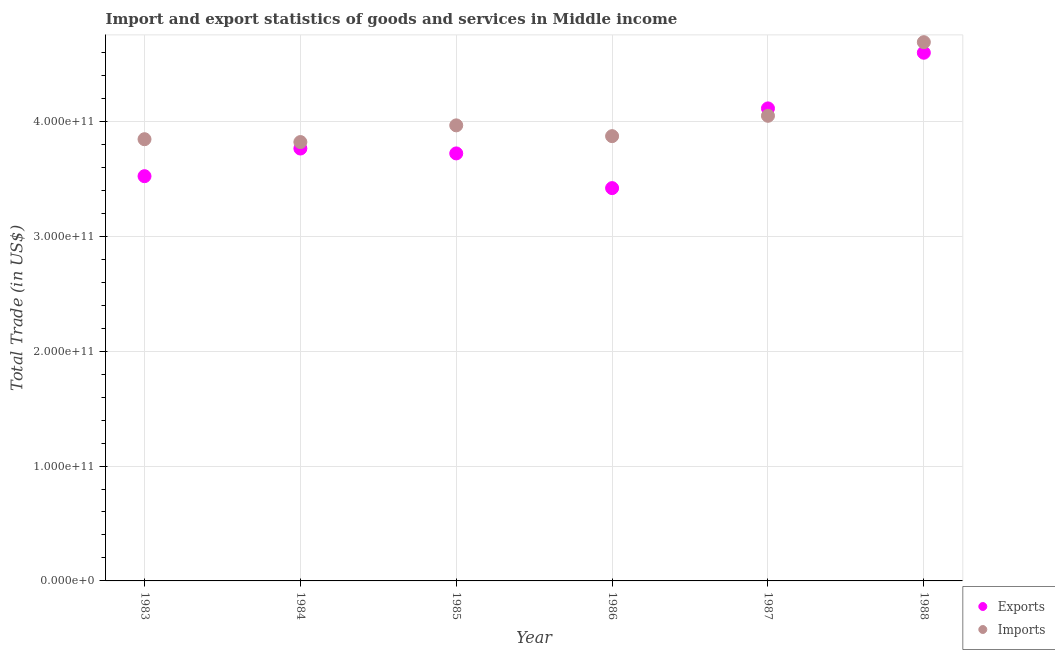How many different coloured dotlines are there?
Make the answer very short. 2. What is the export of goods and services in 1987?
Your response must be concise. 4.11e+11. Across all years, what is the maximum imports of goods and services?
Your answer should be compact. 4.69e+11. Across all years, what is the minimum export of goods and services?
Ensure brevity in your answer.  3.42e+11. What is the total imports of goods and services in the graph?
Keep it short and to the point. 2.42e+12. What is the difference between the export of goods and services in 1984 and that in 1986?
Your answer should be very brief. 3.45e+1. What is the difference between the export of goods and services in 1988 and the imports of goods and services in 1984?
Your answer should be compact. 7.77e+1. What is the average export of goods and services per year?
Offer a terse response. 3.86e+11. In the year 1986, what is the difference between the export of goods and services and imports of goods and services?
Offer a very short reply. -4.52e+1. In how many years, is the imports of goods and services greater than 20000000000 US$?
Offer a very short reply. 6. What is the ratio of the export of goods and services in 1984 to that in 1987?
Your answer should be very brief. 0.92. What is the difference between the highest and the second highest imports of goods and services?
Provide a short and direct response. 6.41e+1. What is the difference between the highest and the lowest imports of goods and services?
Offer a very short reply. 8.69e+1. Is the sum of the export of goods and services in 1986 and 1988 greater than the maximum imports of goods and services across all years?
Keep it short and to the point. Yes. Is the export of goods and services strictly less than the imports of goods and services over the years?
Ensure brevity in your answer.  No. How many dotlines are there?
Your answer should be compact. 2. How many years are there in the graph?
Provide a short and direct response. 6. What is the difference between two consecutive major ticks on the Y-axis?
Offer a very short reply. 1.00e+11. Where does the legend appear in the graph?
Your answer should be very brief. Bottom right. How are the legend labels stacked?
Your answer should be very brief. Vertical. What is the title of the graph?
Your answer should be very brief. Import and export statistics of goods and services in Middle income. What is the label or title of the X-axis?
Offer a very short reply. Year. What is the label or title of the Y-axis?
Offer a very short reply. Total Trade (in US$). What is the Total Trade (in US$) of Exports in 1983?
Your response must be concise. 3.52e+11. What is the Total Trade (in US$) in Imports in 1983?
Your response must be concise. 3.84e+11. What is the Total Trade (in US$) in Exports in 1984?
Keep it short and to the point. 3.76e+11. What is the Total Trade (in US$) of Imports in 1984?
Offer a terse response. 3.82e+11. What is the Total Trade (in US$) of Exports in 1985?
Make the answer very short. 3.72e+11. What is the Total Trade (in US$) of Imports in 1985?
Your answer should be very brief. 3.96e+11. What is the Total Trade (in US$) of Exports in 1986?
Ensure brevity in your answer.  3.42e+11. What is the Total Trade (in US$) in Imports in 1986?
Keep it short and to the point. 3.87e+11. What is the Total Trade (in US$) in Exports in 1987?
Offer a terse response. 4.11e+11. What is the Total Trade (in US$) of Imports in 1987?
Your answer should be compact. 4.05e+11. What is the Total Trade (in US$) of Exports in 1988?
Provide a short and direct response. 4.60e+11. What is the Total Trade (in US$) of Imports in 1988?
Ensure brevity in your answer.  4.69e+11. Across all years, what is the maximum Total Trade (in US$) in Exports?
Offer a terse response. 4.60e+11. Across all years, what is the maximum Total Trade (in US$) of Imports?
Give a very brief answer. 4.69e+11. Across all years, what is the minimum Total Trade (in US$) in Exports?
Offer a very short reply. 3.42e+11. Across all years, what is the minimum Total Trade (in US$) in Imports?
Your answer should be compact. 3.82e+11. What is the total Total Trade (in US$) of Exports in the graph?
Provide a short and direct response. 2.31e+12. What is the total Total Trade (in US$) in Imports in the graph?
Your answer should be very brief. 2.42e+12. What is the difference between the Total Trade (in US$) of Exports in 1983 and that in 1984?
Offer a terse response. -2.41e+1. What is the difference between the Total Trade (in US$) of Imports in 1983 and that in 1984?
Offer a very short reply. 2.48e+09. What is the difference between the Total Trade (in US$) of Exports in 1983 and that in 1985?
Your answer should be compact. -1.98e+1. What is the difference between the Total Trade (in US$) of Imports in 1983 and that in 1985?
Provide a short and direct response. -1.20e+1. What is the difference between the Total Trade (in US$) of Exports in 1983 and that in 1986?
Your answer should be compact. 1.04e+1. What is the difference between the Total Trade (in US$) of Imports in 1983 and that in 1986?
Offer a terse response. -2.66e+09. What is the difference between the Total Trade (in US$) in Exports in 1983 and that in 1987?
Give a very brief answer. -5.90e+1. What is the difference between the Total Trade (in US$) of Imports in 1983 and that in 1987?
Your answer should be compact. -2.04e+1. What is the difference between the Total Trade (in US$) of Exports in 1983 and that in 1988?
Provide a succinct answer. -1.07e+11. What is the difference between the Total Trade (in US$) in Imports in 1983 and that in 1988?
Your answer should be very brief. -8.45e+1. What is the difference between the Total Trade (in US$) of Exports in 1984 and that in 1985?
Your answer should be very brief. 4.25e+09. What is the difference between the Total Trade (in US$) in Imports in 1984 and that in 1985?
Make the answer very short. -1.45e+1. What is the difference between the Total Trade (in US$) in Exports in 1984 and that in 1986?
Offer a very short reply. 3.45e+1. What is the difference between the Total Trade (in US$) of Imports in 1984 and that in 1986?
Offer a terse response. -5.14e+09. What is the difference between the Total Trade (in US$) in Exports in 1984 and that in 1987?
Keep it short and to the point. -3.49e+1. What is the difference between the Total Trade (in US$) in Imports in 1984 and that in 1987?
Provide a short and direct response. -2.29e+1. What is the difference between the Total Trade (in US$) in Exports in 1984 and that in 1988?
Ensure brevity in your answer.  -8.34e+1. What is the difference between the Total Trade (in US$) of Imports in 1984 and that in 1988?
Keep it short and to the point. -8.69e+1. What is the difference between the Total Trade (in US$) in Exports in 1985 and that in 1986?
Provide a succinct answer. 3.02e+1. What is the difference between the Total Trade (in US$) of Imports in 1985 and that in 1986?
Your response must be concise. 9.39e+09. What is the difference between the Total Trade (in US$) of Exports in 1985 and that in 1987?
Provide a succinct answer. -3.92e+1. What is the difference between the Total Trade (in US$) of Imports in 1985 and that in 1987?
Offer a very short reply. -8.33e+09. What is the difference between the Total Trade (in US$) of Exports in 1985 and that in 1988?
Offer a very short reply. -8.76e+1. What is the difference between the Total Trade (in US$) of Imports in 1985 and that in 1988?
Make the answer very short. -7.24e+1. What is the difference between the Total Trade (in US$) of Exports in 1986 and that in 1987?
Provide a short and direct response. -6.94e+1. What is the difference between the Total Trade (in US$) of Imports in 1986 and that in 1987?
Your answer should be compact. -1.77e+1. What is the difference between the Total Trade (in US$) of Exports in 1986 and that in 1988?
Your answer should be compact. -1.18e+11. What is the difference between the Total Trade (in US$) in Imports in 1986 and that in 1988?
Give a very brief answer. -8.18e+1. What is the difference between the Total Trade (in US$) of Exports in 1987 and that in 1988?
Keep it short and to the point. -4.84e+1. What is the difference between the Total Trade (in US$) of Imports in 1987 and that in 1988?
Offer a very short reply. -6.41e+1. What is the difference between the Total Trade (in US$) of Exports in 1983 and the Total Trade (in US$) of Imports in 1984?
Your answer should be compact. -2.97e+1. What is the difference between the Total Trade (in US$) in Exports in 1983 and the Total Trade (in US$) in Imports in 1985?
Offer a very short reply. -4.42e+1. What is the difference between the Total Trade (in US$) in Exports in 1983 and the Total Trade (in US$) in Imports in 1986?
Provide a short and direct response. -3.48e+1. What is the difference between the Total Trade (in US$) of Exports in 1983 and the Total Trade (in US$) of Imports in 1987?
Give a very brief answer. -5.26e+1. What is the difference between the Total Trade (in US$) of Exports in 1983 and the Total Trade (in US$) of Imports in 1988?
Your response must be concise. -1.17e+11. What is the difference between the Total Trade (in US$) in Exports in 1984 and the Total Trade (in US$) in Imports in 1985?
Your response must be concise. -2.02e+1. What is the difference between the Total Trade (in US$) of Exports in 1984 and the Total Trade (in US$) of Imports in 1986?
Offer a very short reply. -1.08e+1. What is the difference between the Total Trade (in US$) in Exports in 1984 and the Total Trade (in US$) in Imports in 1987?
Offer a very short reply. -2.85e+1. What is the difference between the Total Trade (in US$) in Exports in 1984 and the Total Trade (in US$) in Imports in 1988?
Ensure brevity in your answer.  -9.26e+1. What is the difference between the Total Trade (in US$) of Exports in 1985 and the Total Trade (in US$) of Imports in 1986?
Your answer should be very brief. -1.50e+1. What is the difference between the Total Trade (in US$) of Exports in 1985 and the Total Trade (in US$) of Imports in 1987?
Your response must be concise. -3.27e+1. What is the difference between the Total Trade (in US$) in Exports in 1985 and the Total Trade (in US$) in Imports in 1988?
Your answer should be compact. -9.68e+1. What is the difference between the Total Trade (in US$) in Exports in 1986 and the Total Trade (in US$) in Imports in 1987?
Keep it short and to the point. -6.29e+1. What is the difference between the Total Trade (in US$) of Exports in 1986 and the Total Trade (in US$) of Imports in 1988?
Keep it short and to the point. -1.27e+11. What is the difference between the Total Trade (in US$) in Exports in 1987 and the Total Trade (in US$) in Imports in 1988?
Offer a terse response. -5.76e+1. What is the average Total Trade (in US$) of Exports per year?
Give a very brief answer. 3.86e+11. What is the average Total Trade (in US$) in Imports per year?
Your answer should be very brief. 4.04e+11. In the year 1983, what is the difference between the Total Trade (in US$) in Exports and Total Trade (in US$) in Imports?
Your answer should be compact. -3.22e+1. In the year 1984, what is the difference between the Total Trade (in US$) of Exports and Total Trade (in US$) of Imports?
Offer a very short reply. -5.64e+09. In the year 1985, what is the difference between the Total Trade (in US$) of Exports and Total Trade (in US$) of Imports?
Give a very brief answer. -2.44e+1. In the year 1986, what is the difference between the Total Trade (in US$) of Exports and Total Trade (in US$) of Imports?
Give a very brief answer. -4.52e+1. In the year 1987, what is the difference between the Total Trade (in US$) of Exports and Total Trade (in US$) of Imports?
Keep it short and to the point. 6.44e+09. In the year 1988, what is the difference between the Total Trade (in US$) of Exports and Total Trade (in US$) of Imports?
Offer a terse response. -9.19e+09. What is the ratio of the Total Trade (in US$) in Exports in 1983 to that in 1984?
Give a very brief answer. 0.94. What is the ratio of the Total Trade (in US$) in Exports in 1983 to that in 1985?
Ensure brevity in your answer.  0.95. What is the ratio of the Total Trade (in US$) of Imports in 1983 to that in 1985?
Offer a very short reply. 0.97. What is the ratio of the Total Trade (in US$) of Exports in 1983 to that in 1986?
Your response must be concise. 1.03. What is the ratio of the Total Trade (in US$) of Imports in 1983 to that in 1986?
Keep it short and to the point. 0.99. What is the ratio of the Total Trade (in US$) in Exports in 1983 to that in 1987?
Offer a terse response. 0.86. What is the ratio of the Total Trade (in US$) of Imports in 1983 to that in 1987?
Provide a succinct answer. 0.95. What is the ratio of the Total Trade (in US$) of Exports in 1983 to that in 1988?
Your answer should be compact. 0.77. What is the ratio of the Total Trade (in US$) in Imports in 1983 to that in 1988?
Make the answer very short. 0.82. What is the ratio of the Total Trade (in US$) of Exports in 1984 to that in 1985?
Give a very brief answer. 1.01. What is the ratio of the Total Trade (in US$) of Imports in 1984 to that in 1985?
Offer a very short reply. 0.96. What is the ratio of the Total Trade (in US$) of Exports in 1984 to that in 1986?
Your answer should be very brief. 1.1. What is the ratio of the Total Trade (in US$) of Imports in 1984 to that in 1986?
Provide a short and direct response. 0.99. What is the ratio of the Total Trade (in US$) of Exports in 1984 to that in 1987?
Give a very brief answer. 0.92. What is the ratio of the Total Trade (in US$) in Imports in 1984 to that in 1987?
Offer a very short reply. 0.94. What is the ratio of the Total Trade (in US$) in Exports in 1984 to that in 1988?
Your response must be concise. 0.82. What is the ratio of the Total Trade (in US$) in Imports in 1984 to that in 1988?
Provide a short and direct response. 0.81. What is the ratio of the Total Trade (in US$) in Exports in 1985 to that in 1986?
Keep it short and to the point. 1.09. What is the ratio of the Total Trade (in US$) in Imports in 1985 to that in 1986?
Your answer should be compact. 1.02. What is the ratio of the Total Trade (in US$) in Exports in 1985 to that in 1987?
Your answer should be very brief. 0.9. What is the ratio of the Total Trade (in US$) in Imports in 1985 to that in 1987?
Your answer should be very brief. 0.98. What is the ratio of the Total Trade (in US$) in Exports in 1985 to that in 1988?
Provide a short and direct response. 0.81. What is the ratio of the Total Trade (in US$) of Imports in 1985 to that in 1988?
Your response must be concise. 0.85. What is the ratio of the Total Trade (in US$) in Exports in 1986 to that in 1987?
Make the answer very short. 0.83. What is the ratio of the Total Trade (in US$) of Imports in 1986 to that in 1987?
Offer a terse response. 0.96. What is the ratio of the Total Trade (in US$) of Exports in 1986 to that in 1988?
Give a very brief answer. 0.74. What is the ratio of the Total Trade (in US$) of Imports in 1986 to that in 1988?
Offer a very short reply. 0.83. What is the ratio of the Total Trade (in US$) of Exports in 1987 to that in 1988?
Ensure brevity in your answer.  0.89. What is the ratio of the Total Trade (in US$) of Imports in 1987 to that in 1988?
Ensure brevity in your answer.  0.86. What is the difference between the highest and the second highest Total Trade (in US$) of Exports?
Offer a very short reply. 4.84e+1. What is the difference between the highest and the second highest Total Trade (in US$) of Imports?
Your answer should be compact. 6.41e+1. What is the difference between the highest and the lowest Total Trade (in US$) in Exports?
Offer a terse response. 1.18e+11. What is the difference between the highest and the lowest Total Trade (in US$) in Imports?
Your answer should be compact. 8.69e+1. 